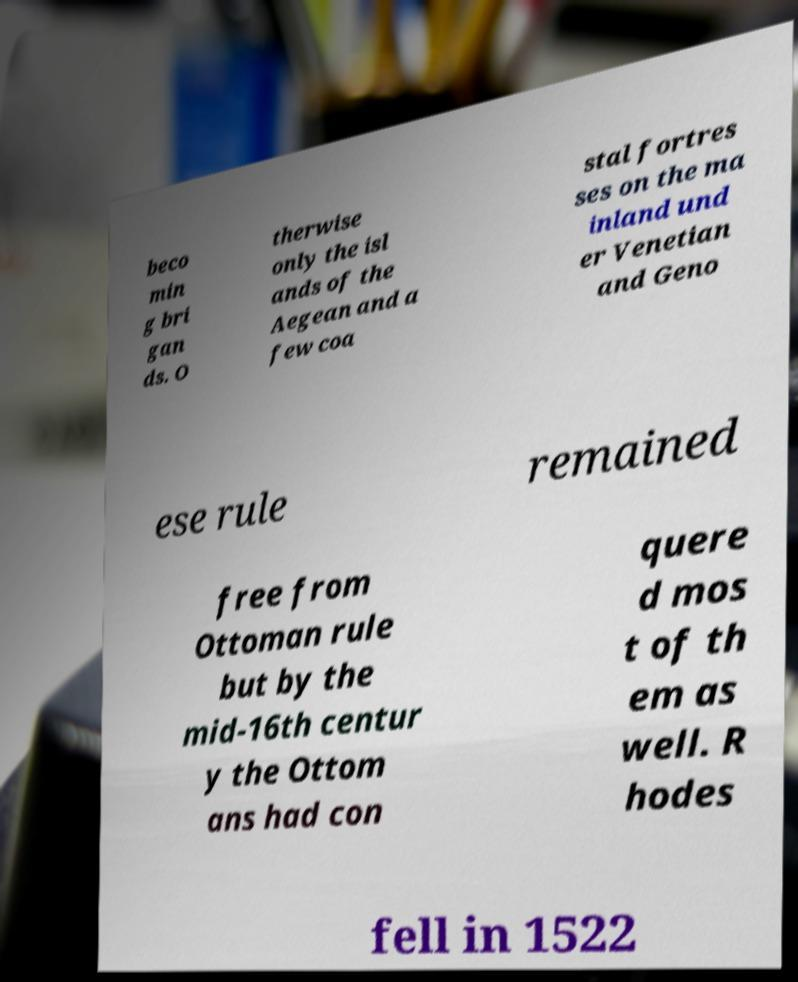Could you assist in decoding the text presented in this image and type it out clearly? beco min g bri gan ds. O therwise only the isl ands of the Aegean and a few coa stal fortres ses on the ma inland und er Venetian and Geno ese rule remained free from Ottoman rule but by the mid-16th centur y the Ottom ans had con quere d mos t of th em as well. R hodes fell in 1522 